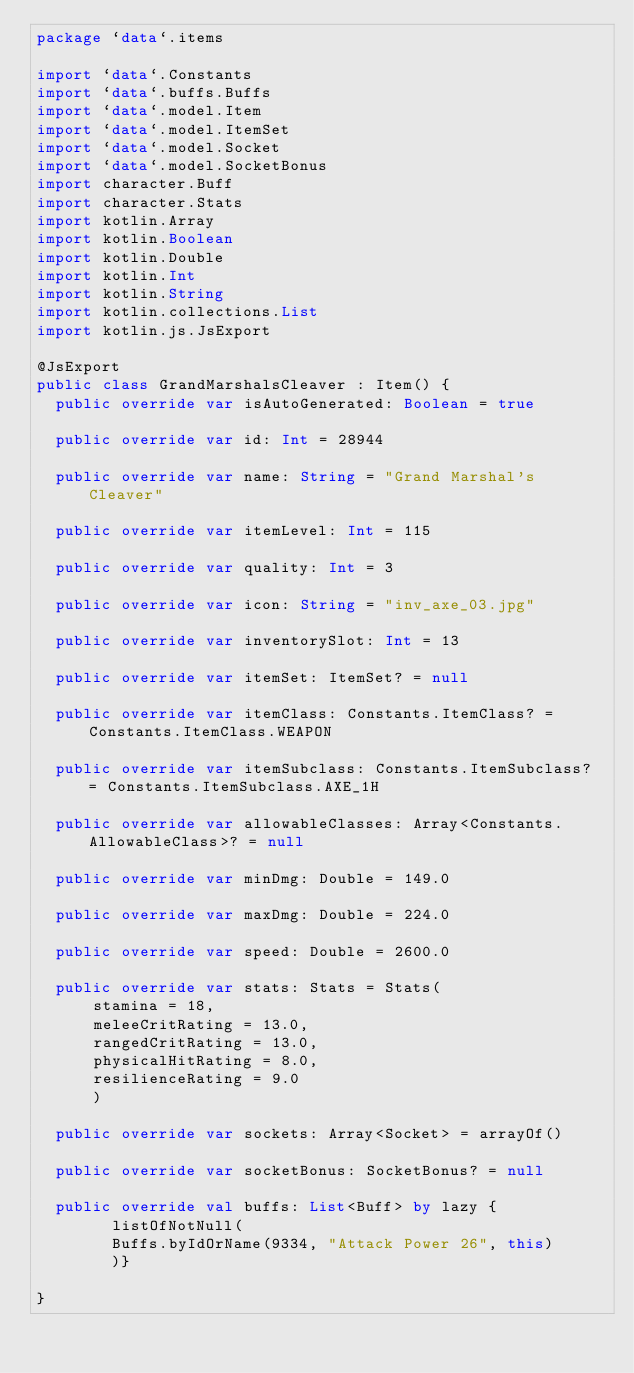<code> <loc_0><loc_0><loc_500><loc_500><_Kotlin_>package `data`.items

import `data`.Constants
import `data`.buffs.Buffs
import `data`.model.Item
import `data`.model.ItemSet
import `data`.model.Socket
import `data`.model.SocketBonus
import character.Buff
import character.Stats
import kotlin.Array
import kotlin.Boolean
import kotlin.Double
import kotlin.Int
import kotlin.String
import kotlin.collections.List
import kotlin.js.JsExport

@JsExport
public class GrandMarshalsCleaver : Item() {
  public override var isAutoGenerated: Boolean = true

  public override var id: Int = 28944

  public override var name: String = "Grand Marshal's Cleaver"

  public override var itemLevel: Int = 115

  public override var quality: Int = 3

  public override var icon: String = "inv_axe_03.jpg"

  public override var inventorySlot: Int = 13

  public override var itemSet: ItemSet? = null

  public override var itemClass: Constants.ItemClass? = Constants.ItemClass.WEAPON

  public override var itemSubclass: Constants.ItemSubclass? = Constants.ItemSubclass.AXE_1H

  public override var allowableClasses: Array<Constants.AllowableClass>? = null

  public override var minDmg: Double = 149.0

  public override var maxDmg: Double = 224.0

  public override var speed: Double = 2600.0

  public override var stats: Stats = Stats(
      stamina = 18,
      meleeCritRating = 13.0,
      rangedCritRating = 13.0,
      physicalHitRating = 8.0,
      resilienceRating = 9.0
      )

  public override var sockets: Array<Socket> = arrayOf()

  public override var socketBonus: SocketBonus? = null

  public override val buffs: List<Buff> by lazy {
        listOfNotNull(
        Buffs.byIdOrName(9334, "Attack Power 26", this)
        )}

}
</code> 